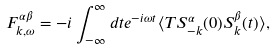<formula> <loc_0><loc_0><loc_500><loc_500>F ^ { \alpha \beta } _ { { k } , \omega } = - i \int _ { - \infty } ^ { \infty } d t e ^ { - i \omega t } \langle T S ^ { \alpha } _ { - { k } } ( 0 ) S ^ { \beta } _ { k } ( t ) \rangle ,</formula> 